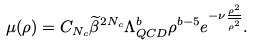<formula> <loc_0><loc_0><loc_500><loc_500>\mu ( \rho ) = C _ { N _ { c } } \widetilde { \beta } ^ { 2 N _ { c } } \Lambda _ { Q C D } ^ { b } \rho ^ { b - 5 } e ^ { - \nu \frac { \rho ^ { 2 } } { \overline { \rho ^ { 2 } } } } .</formula> 